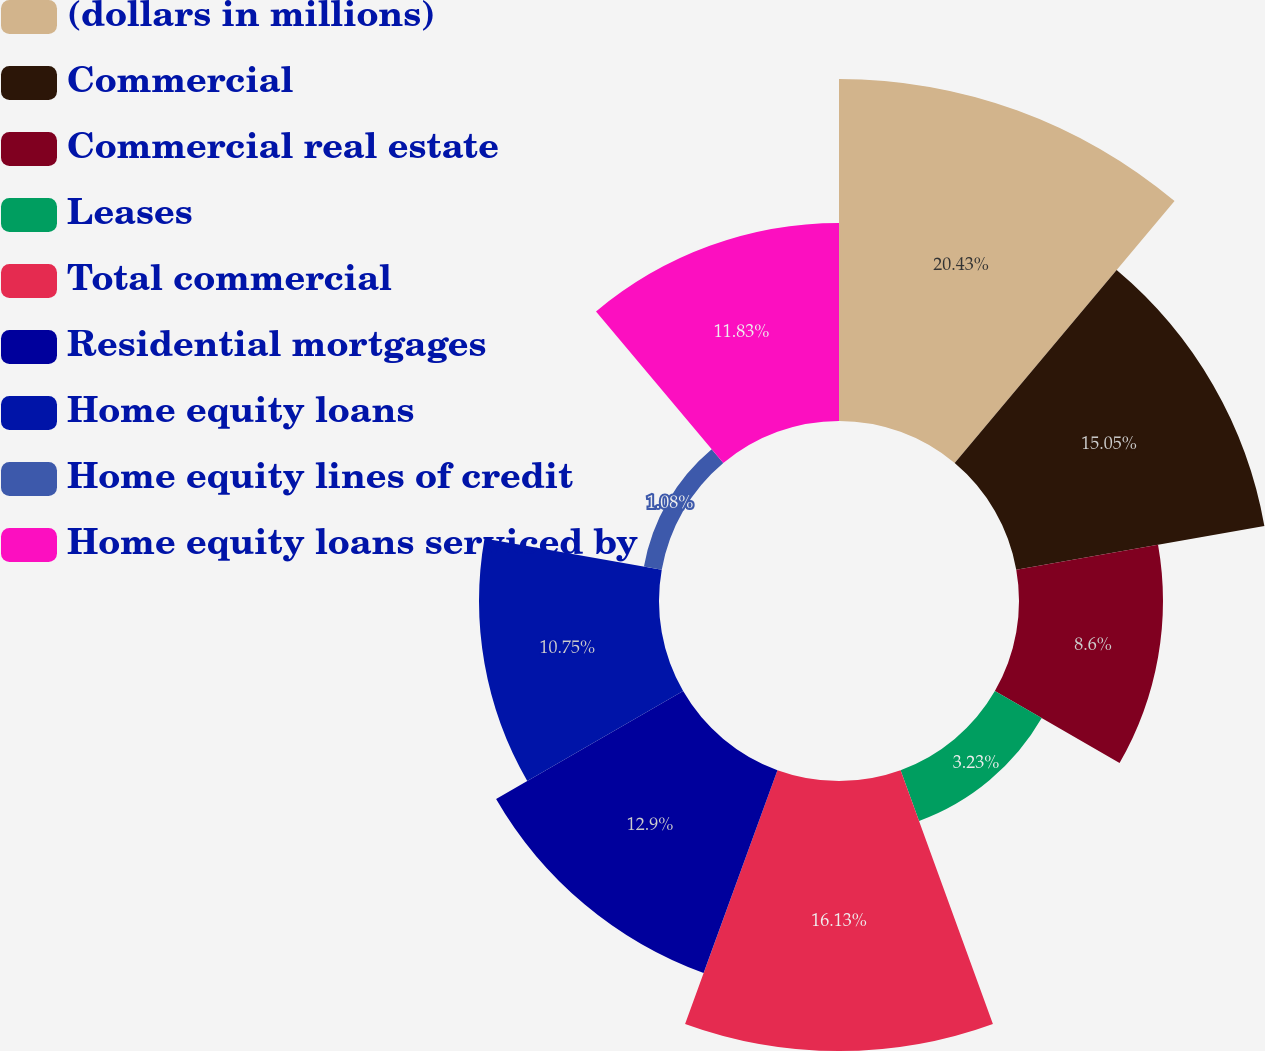Convert chart. <chart><loc_0><loc_0><loc_500><loc_500><pie_chart><fcel>(dollars in millions)<fcel>Commercial<fcel>Commercial real estate<fcel>Leases<fcel>Total commercial<fcel>Residential mortgages<fcel>Home equity loans<fcel>Home equity lines of credit<fcel>Home equity loans serviced by<nl><fcel>20.43%<fcel>15.05%<fcel>8.6%<fcel>3.23%<fcel>16.13%<fcel>12.9%<fcel>10.75%<fcel>1.08%<fcel>11.83%<nl></chart> 